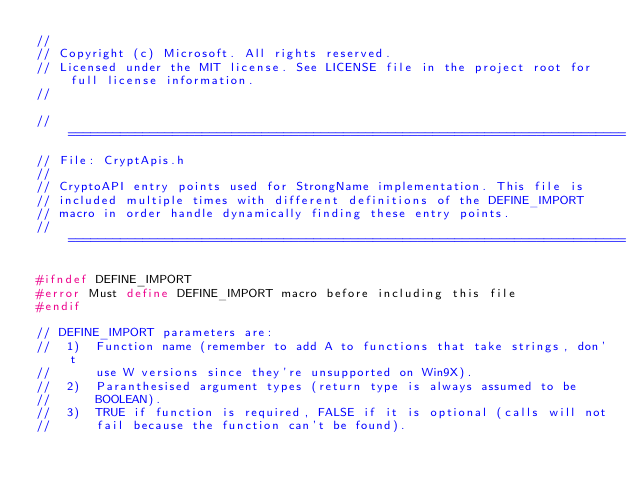<code> <loc_0><loc_0><loc_500><loc_500><_C_>//
// Copyright (c) Microsoft. All rights reserved.
// Licensed under the MIT license. See LICENSE file in the project root for full license information.
//

// ===========================================================================
// File: CryptApis.h
// 
// CryptoAPI entry points used for StrongName implementation. This file is
// included multiple times with different definitions of the DEFINE_IMPORT
// macro in order handle dynamically finding these entry points.
// ===========================================================================

#ifndef DEFINE_IMPORT
#error Must define DEFINE_IMPORT macro before including this file
#endif

// DEFINE_IMPORT parameters are:
//  1)  Function name (remember to add A to functions that take strings, don't
//      use W versions since they're unsupported on Win9X).
//  2)  Paranthesised argument types (return type is always assumed to be
//      BOOLEAN).
//  3)  TRUE if function is required, FALSE if it is optional (calls will not
//      fail because the function can't be found).
</code> 